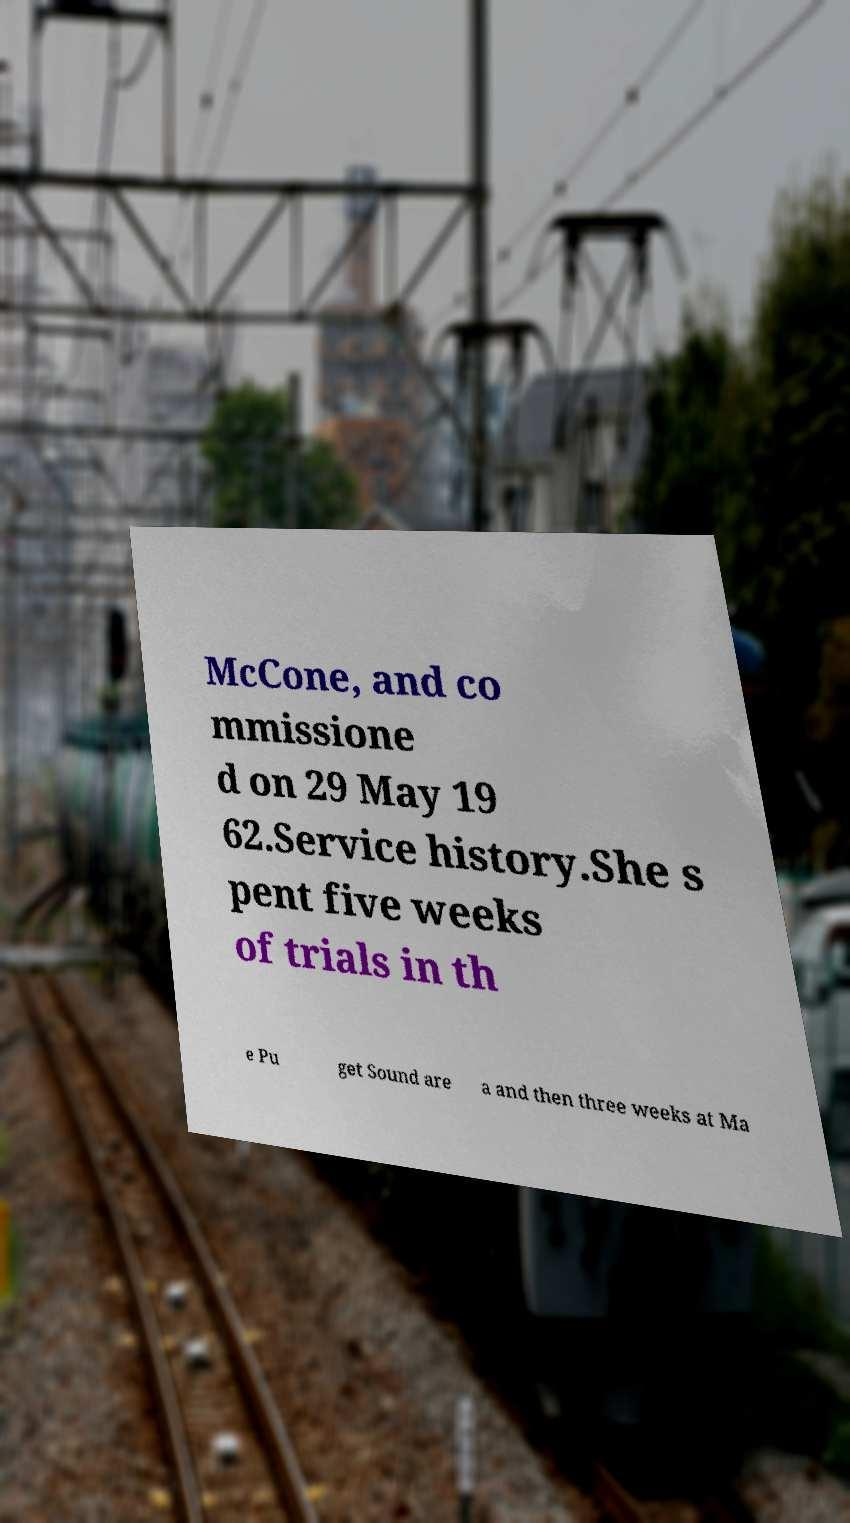Can you accurately transcribe the text from the provided image for me? McCone, and co mmissione d on 29 May 19 62.Service history.She s pent five weeks of trials in th e Pu get Sound are a and then three weeks at Ma 